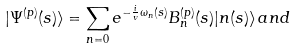Convert formula to latex. <formula><loc_0><loc_0><loc_500><loc_500>| \Psi ^ { ( p ) } ( s ) \rangle = \sum _ { n = 0 } e ^ { - \frac { i } { v } \omega _ { n } ( s ) } B _ { n } ^ { ( p ) } ( s ) | n ( s ) \rangle \, a n d</formula> 